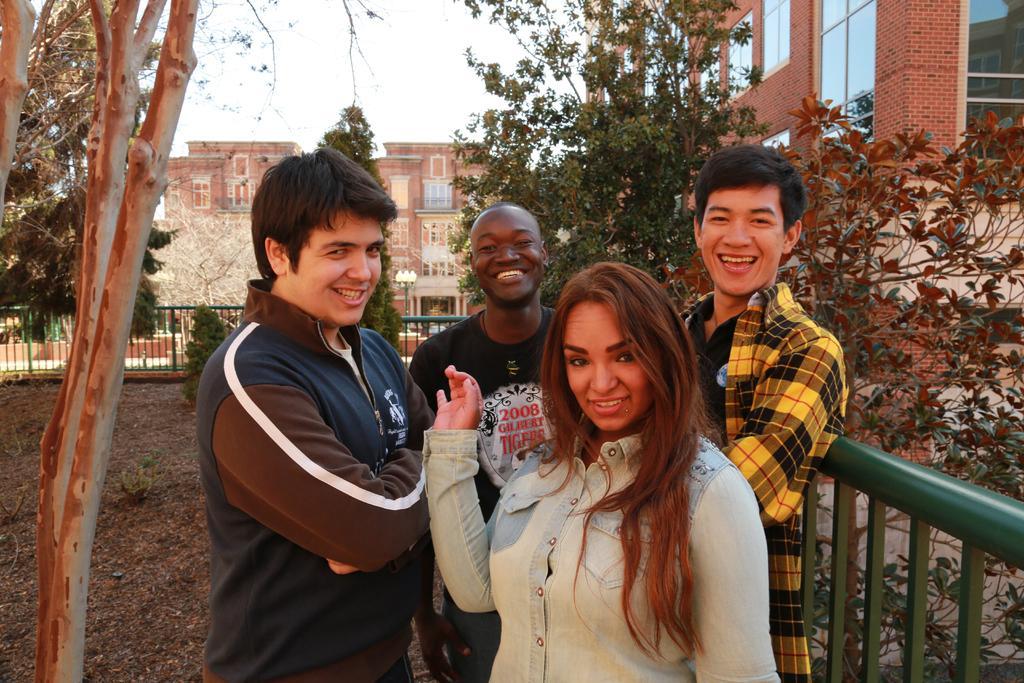How would you summarize this image in a sentence or two? In this image there are four people standing near the fence, there are few leaves on the ground, few trees, few buildings and the sky. 